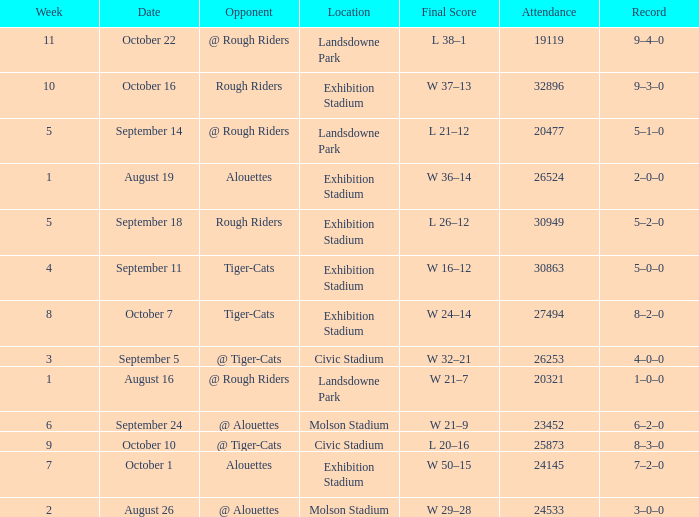What is the least value for week? 1.0. 